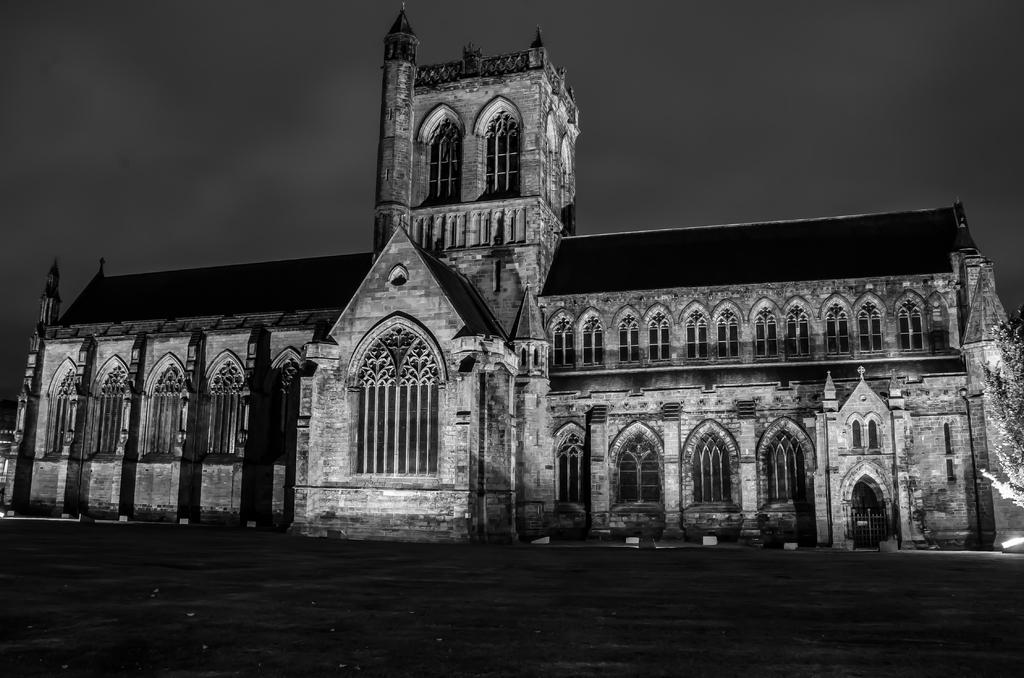What type of surface is visible in the image? There is ground visible in the image. What type of natural element can be seen in the image? There is a tree in the image. What type of structure is present in the image? There is a building with windows in the image. What can be seen in the distance in the image? The sky is visible in the background of the image. How many ladybugs are crawling on the tree in the image? There are no ladybugs present in the image; it only features a tree. What type of town is visible in the background of the image? There is no town visible in the image; it only features a building, tree, ground, and sky. 